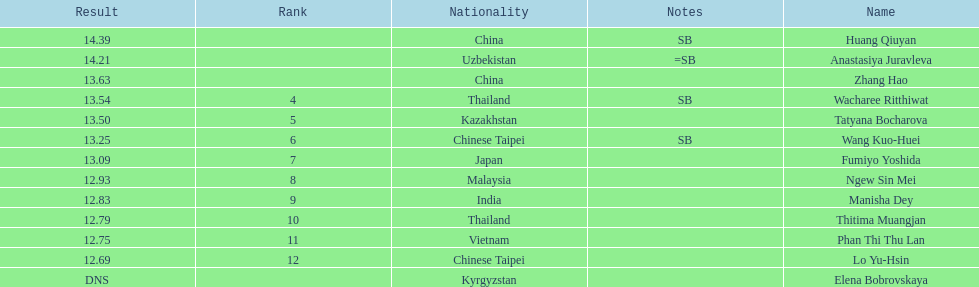What was the length of manisha dey's jump? 12.83. 